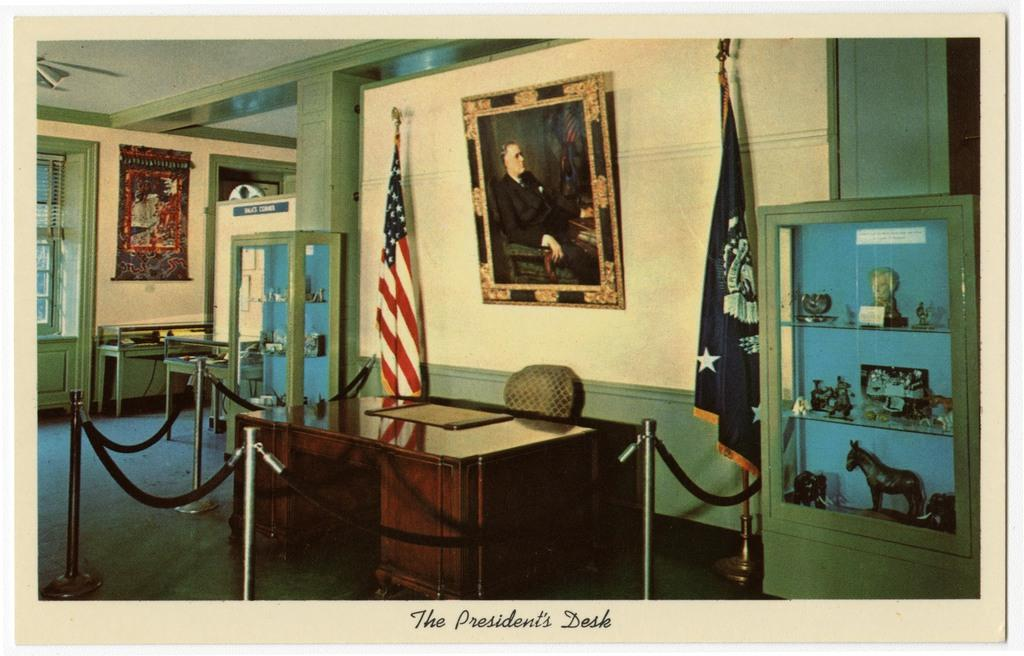What objects are in the foreground of the image? There is a table, a chair, a showcase, flags, and a photograph in the foreground of the image. Can you describe the objects in the foreground? The table and chair are furniture, the showcase likely displays items, the flags represent a country or organization, and the photograph is a visual representation of a person or event. What can be seen in the background of the image? It seems like there are racks, a window, and a poster in the background of the image. Can you describe the objects in the background? The racks might hold items or serve as storage, the window provides natural light and a view of the outside, and the poster is a visual display of information or art. What type of arithmetic problem can be solved using the beans in the image? There are no beans present in the image, so it is not possible to solve an arithmetic problem using them. 